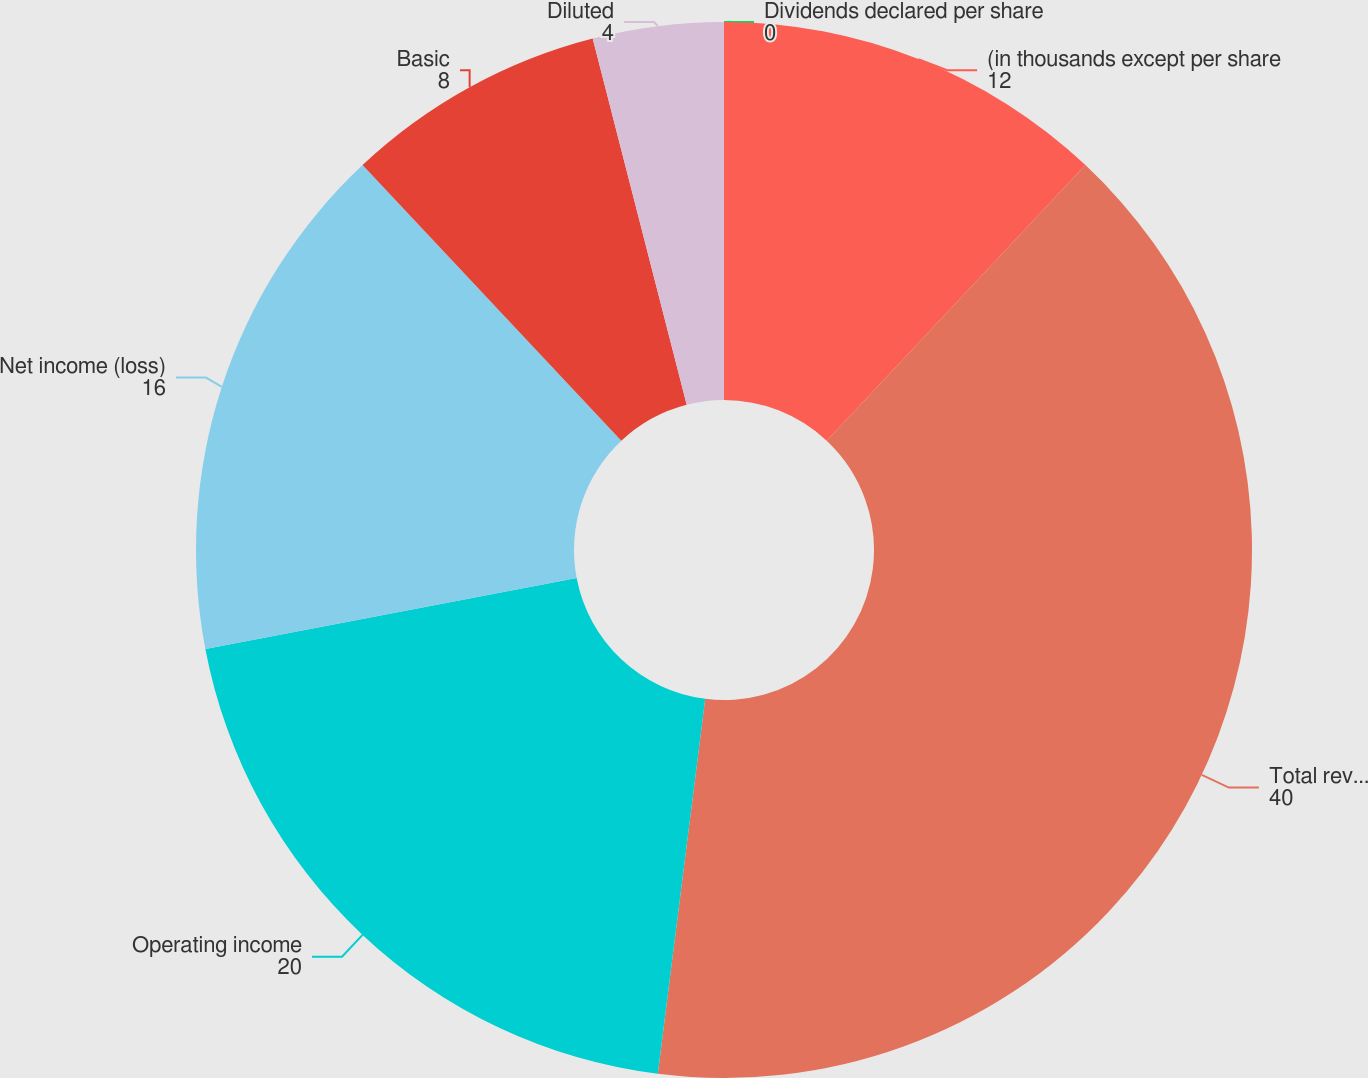<chart> <loc_0><loc_0><loc_500><loc_500><pie_chart><fcel>(in thousands except per share<fcel>Total revenues 1<fcel>Operating income<fcel>Net income (loss)<fcel>Basic<fcel>Diluted<fcel>Dividends declared per share<nl><fcel>12.0%<fcel>40.0%<fcel>20.0%<fcel>16.0%<fcel>8.0%<fcel>4.0%<fcel>0.0%<nl></chart> 